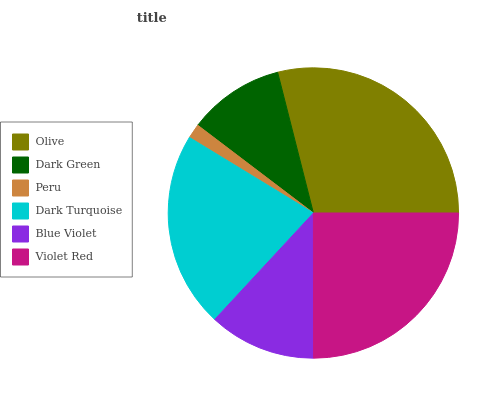Is Peru the minimum?
Answer yes or no. Yes. Is Olive the maximum?
Answer yes or no. Yes. Is Dark Green the minimum?
Answer yes or no. No. Is Dark Green the maximum?
Answer yes or no. No. Is Olive greater than Dark Green?
Answer yes or no. Yes. Is Dark Green less than Olive?
Answer yes or no. Yes. Is Dark Green greater than Olive?
Answer yes or no. No. Is Olive less than Dark Green?
Answer yes or no. No. Is Dark Turquoise the high median?
Answer yes or no. Yes. Is Blue Violet the low median?
Answer yes or no. Yes. Is Peru the high median?
Answer yes or no. No. Is Violet Red the low median?
Answer yes or no. No. 